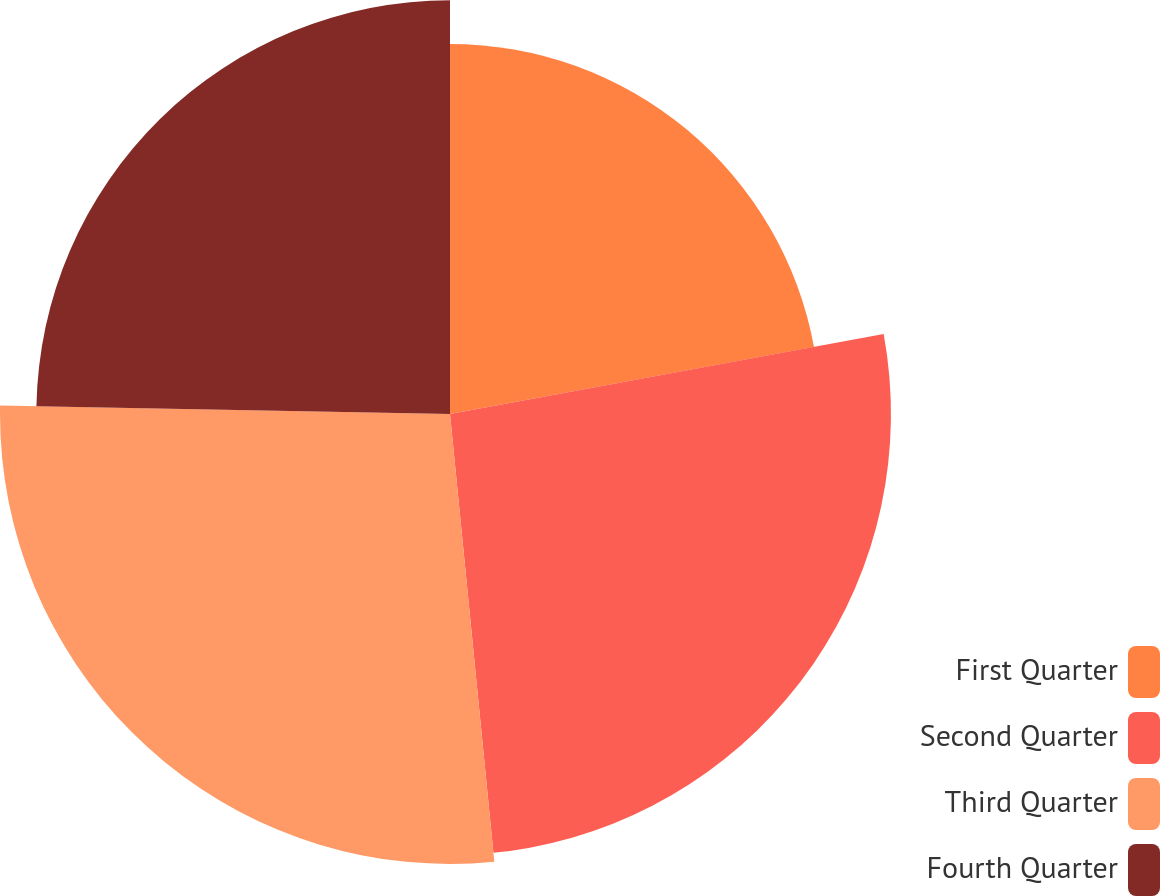Convert chart. <chart><loc_0><loc_0><loc_500><loc_500><pie_chart><fcel>First Quarter<fcel>Second Quarter<fcel>Third Quarter<fcel>Fourth Quarter<nl><fcel>22.1%<fcel>26.33%<fcel>26.87%<fcel>24.7%<nl></chart> 